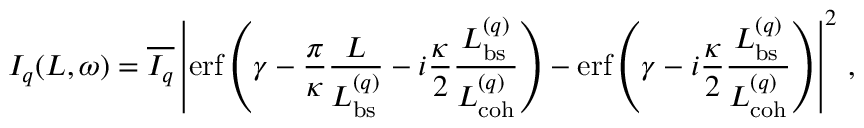<formula> <loc_0><loc_0><loc_500><loc_500>I _ { q } ( L , \omega ) = \overline { { I _ { q } } } \left | e r f \left ( \gamma - \frac { \pi } { \kappa } \frac { L } { L _ { b s } ^ { ( q ) } } - i \frac { \kappa } { 2 } \frac { L _ { b s } ^ { ( q ) } } { L _ { c o h } ^ { ( q ) } } \right ) - e r f \left ( \gamma - i \frac { \kappa } { 2 } \frac { L _ { b s } ^ { ( q ) } } { L _ { c o h } ^ { ( q ) } } \right ) \right | ^ { 2 } \, ,</formula> 